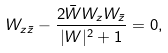Convert formula to latex. <formula><loc_0><loc_0><loc_500><loc_500>W _ { z \bar { z } } - \frac { 2 \bar { W } W _ { z } W _ { \bar { z } } } { | W | ^ { 2 } + 1 } = 0 ,</formula> 